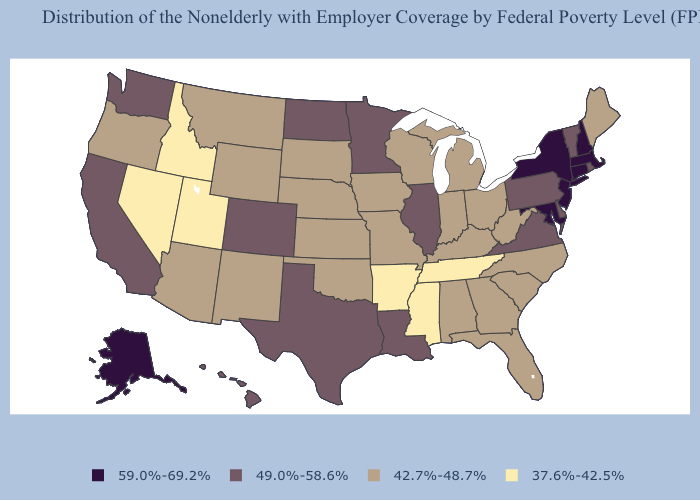What is the lowest value in the USA?
Concise answer only. 37.6%-42.5%. Among the states that border South Dakota , does Wyoming have the highest value?
Give a very brief answer. No. Which states hav the highest value in the MidWest?
Concise answer only. Illinois, Minnesota, North Dakota. Which states have the highest value in the USA?
Concise answer only. Alaska, Connecticut, Maryland, Massachusetts, New Hampshire, New Jersey, New York. Is the legend a continuous bar?
Be succinct. No. What is the lowest value in the USA?
Give a very brief answer. 37.6%-42.5%. Which states have the lowest value in the MidWest?
Quick response, please. Indiana, Iowa, Kansas, Michigan, Missouri, Nebraska, Ohio, South Dakota, Wisconsin. What is the lowest value in states that border Missouri?
Concise answer only. 37.6%-42.5%. Name the states that have a value in the range 49.0%-58.6%?
Quick response, please. California, Colorado, Delaware, Hawaii, Illinois, Louisiana, Minnesota, North Dakota, Pennsylvania, Rhode Island, Texas, Vermont, Virginia, Washington. Does Utah have the lowest value in the West?
Write a very short answer. Yes. What is the highest value in the USA?
Concise answer only. 59.0%-69.2%. Among the states that border Wisconsin , does Illinois have the lowest value?
Write a very short answer. No. Name the states that have a value in the range 37.6%-42.5%?
Keep it brief. Arkansas, Idaho, Mississippi, Nevada, Tennessee, Utah. Among the states that border Maryland , which have the lowest value?
Quick response, please. West Virginia. 